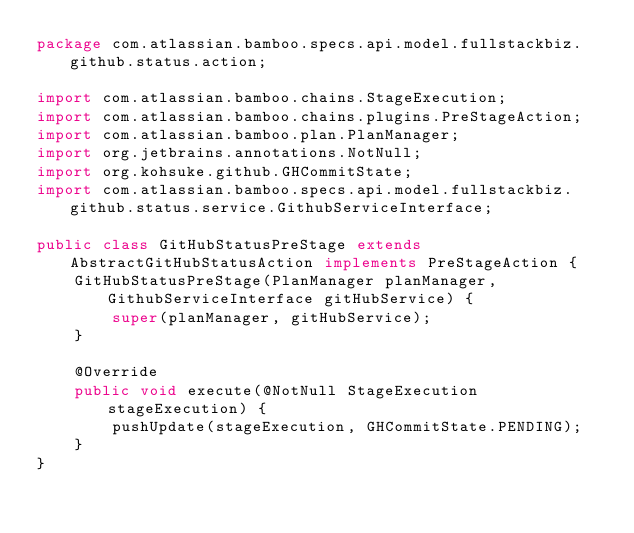Convert code to text. <code><loc_0><loc_0><loc_500><loc_500><_Java_>package com.atlassian.bamboo.specs.api.model.fullstackbiz.github.status.action;

import com.atlassian.bamboo.chains.StageExecution;
import com.atlassian.bamboo.chains.plugins.PreStageAction;
import com.atlassian.bamboo.plan.PlanManager;
import org.jetbrains.annotations.NotNull;
import org.kohsuke.github.GHCommitState;
import com.atlassian.bamboo.specs.api.model.fullstackbiz.github.status.service.GithubServiceInterface;

public class GitHubStatusPreStage extends AbstractGitHubStatusAction implements PreStageAction {
    GitHubStatusPreStage(PlanManager planManager, GithubServiceInterface gitHubService) {
        super(planManager, gitHubService);
    }

    @Override
    public void execute(@NotNull StageExecution stageExecution) {
        pushUpdate(stageExecution, GHCommitState.PENDING);
    }
}
</code> 